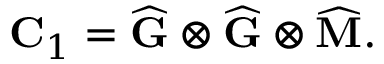Convert formula to latex. <formula><loc_0><loc_0><loc_500><loc_500>C _ { 1 } = \widehat { G } \otimes \widehat { G } \otimes \widehat { M } .</formula> 